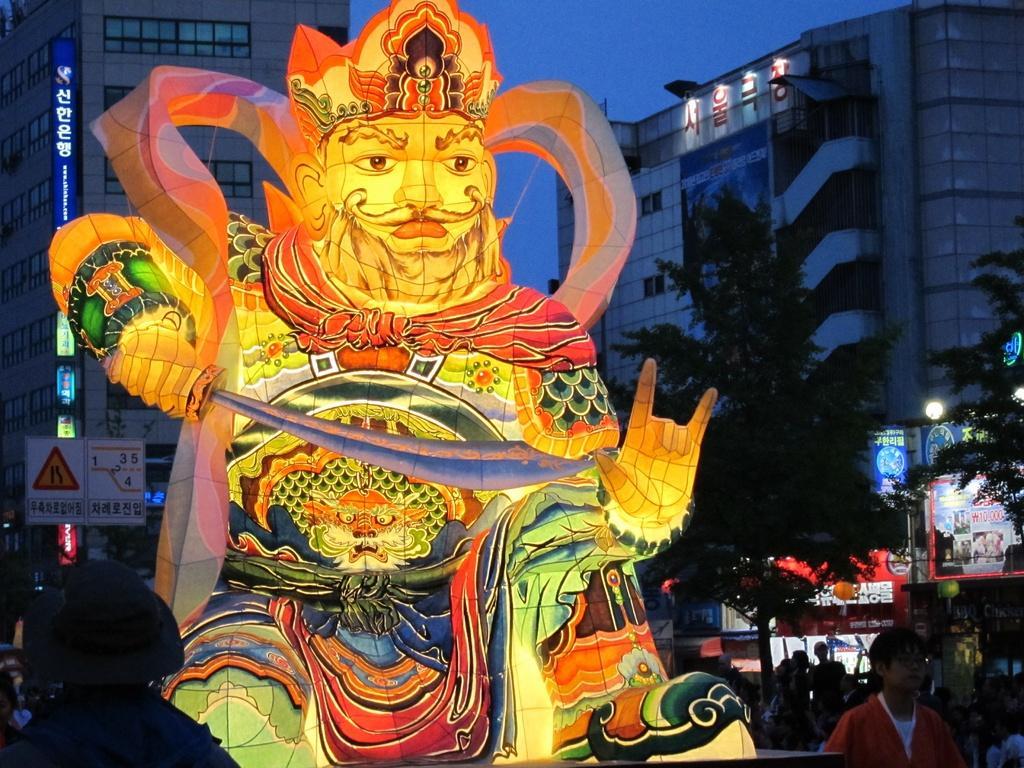Please provide a concise description of this image. In the center of the image there is a statue. At the bottom of the image we can see persons. In the background we can see buildings, persons, vehicles, trees and sky. 